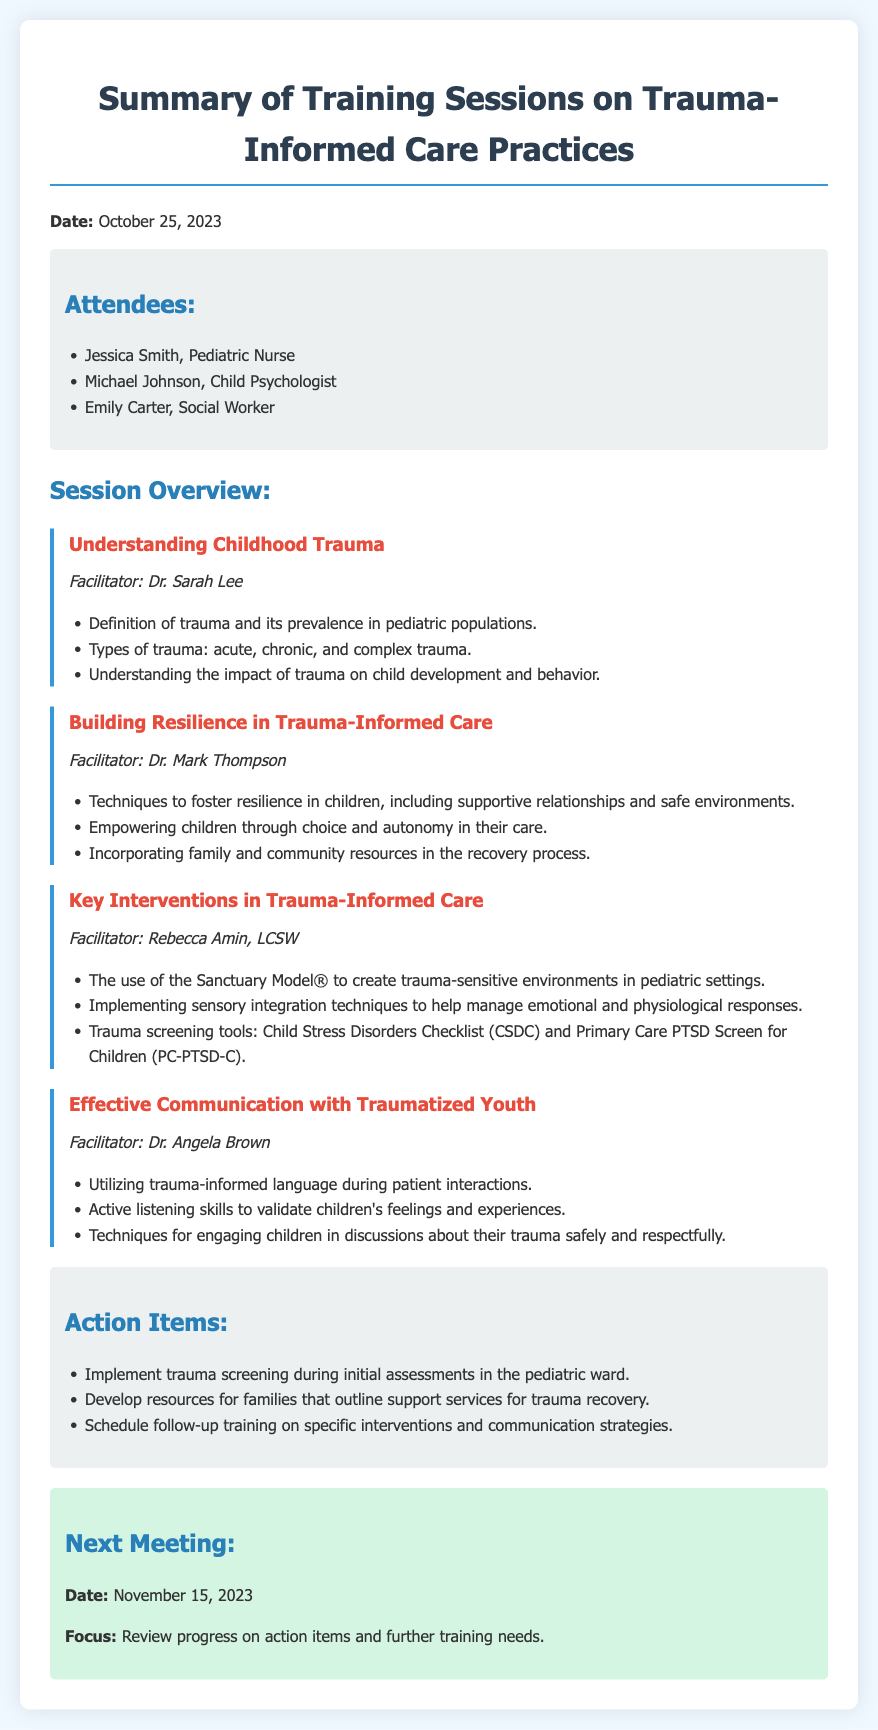What is the date of the training sessions? The date of the training sessions is mentioned at the beginning of the document.
Answer: October 25, 2023 Who facilitated the session on understanding childhood trauma? The facilitator for the session is listed under the session details.
Answer: Dr. Sarah Lee What are the types of trauma discussed in the first session? The document lists the types of trauma covered in the session overview.
Answer: Acute, chronic, and complex trauma What is one of the key techniques to foster resilience mentioned? The document provides a specific technique under the session on building resilience.
Answer: Supportive relationships What action item was suggested for initial assessments in the pediatric ward? The action items section outlines a specific action to be taken during assessments.
Answer: Implement trauma screening How many attendees were present at the training sessions? The number of attendees can be obtained by counting the names listed in the attendees section.
Answer: Three What communication technique is emphasized for engaging children? The document highlights a specific technique in the session about effective communication.
Answer: Active listening skills When is the next meeting scheduled? The date for the next meeting is mentioned in the next meeting section of the document.
Answer: November 15, 2023 What is the main focus of the next meeting? The document states the focus of the next meeting in a specific section.
Answer: Review progress on action items and further training needs 